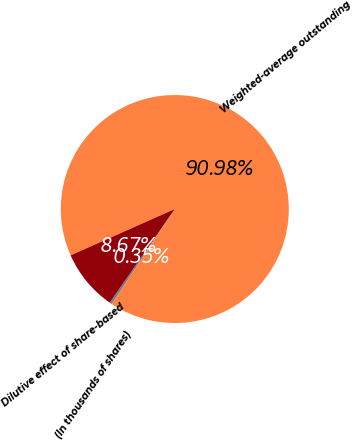Convert chart to OTSL. <chart><loc_0><loc_0><loc_500><loc_500><pie_chart><fcel>(In thousands of shares)<fcel>Weighted-average outstanding<fcel>Dilutive effect of share-based<nl><fcel>0.35%<fcel>90.97%<fcel>8.67%<nl></chart> 